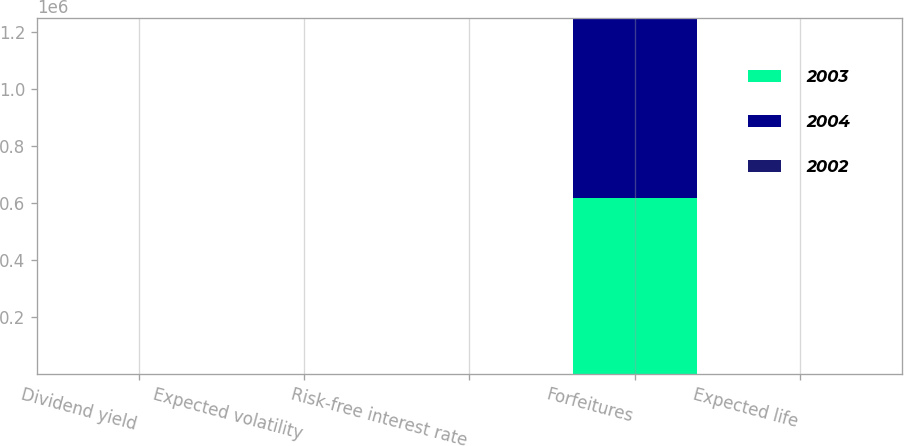Convert chart. <chart><loc_0><loc_0><loc_500><loc_500><stacked_bar_chart><ecel><fcel>Dividend yield<fcel>Expected volatility<fcel>Risk-free interest rate<fcel>Forfeitures<fcel>Expected life<nl><fcel>2003<fcel>0<fcel>46.85<fcel>3.5<fcel>615112<fcel>5<nl><fcel>2004<fcel>0<fcel>49.28<fcel>3.13<fcel>631561<fcel>5<nl><fcel>2002<fcel>0<fcel>49.8<fcel>3.18<fcel>5<fcel>5<nl></chart> 